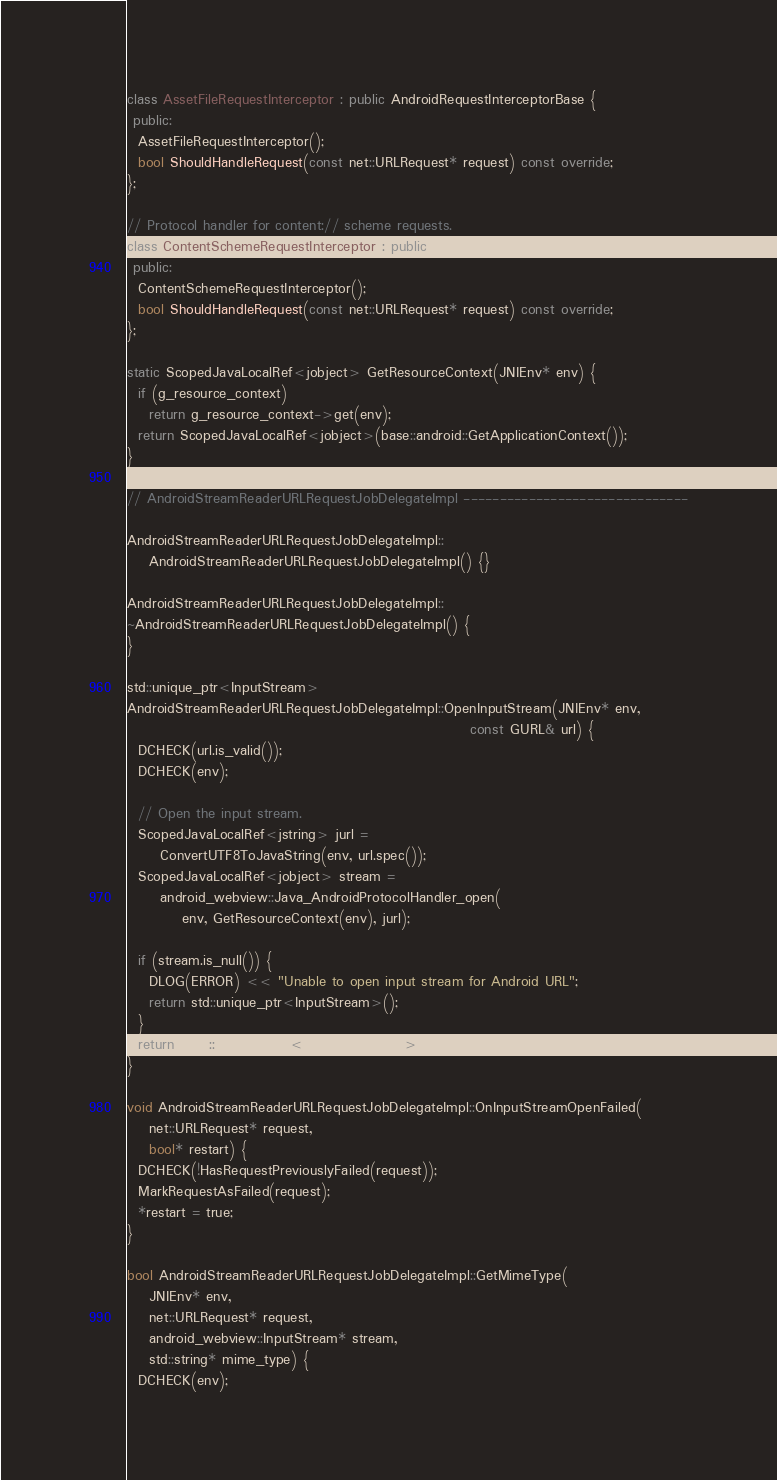<code> <loc_0><loc_0><loc_500><loc_500><_C++_>class AssetFileRequestInterceptor : public AndroidRequestInterceptorBase {
 public:
  AssetFileRequestInterceptor();
  bool ShouldHandleRequest(const net::URLRequest* request) const override;
};

// Protocol handler for content:// scheme requests.
class ContentSchemeRequestInterceptor : public AndroidRequestInterceptorBase {
 public:
  ContentSchemeRequestInterceptor();
  bool ShouldHandleRequest(const net::URLRequest* request) const override;
};

static ScopedJavaLocalRef<jobject> GetResourceContext(JNIEnv* env) {
  if (g_resource_context)
    return g_resource_context->get(env);
  return ScopedJavaLocalRef<jobject>(base::android::GetApplicationContext());
}

// AndroidStreamReaderURLRequestJobDelegateImpl -------------------------------

AndroidStreamReaderURLRequestJobDelegateImpl::
    AndroidStreamReaderURLRequestJobDelegateImpl() {}

AndroidStreamReaderURLRequestJobDelegateImpl::
~AndroidStreamReaderURLRequestJobDelegateImpl() {
}

std::unique_ptr<InputStream>
AndroidStreamReaderURLRequestJobDelegateImpl::OpenInputStream(JNIEnv* env,
                                                              const GURL& url) {
  DCHECK(url.is_valid());
  DCHECK(env);

  // Open the input stream.
  ScopedJavaLocalRef<jstring> jurl =
      ConvertUTF8ToJavaString(env, url.spec());
  ScopedJavaLocalRef<jobject> stream =
      android_webview::Java_AndroidProtocolHandler_open(
          env, GetResourceContext(env), jurl);

  if (stream.is_null()) {
    DLOG(ERROR) << "Unable to open input stream for Android URL";
    return std::unique_ptr<InputStream>();
  }
  return base::MakeUnique<InputStreamImpl>(stream);
}

void AndroidStreamReaderURLRequestJobDelegateImpl::OnInputStreamOpenFailed(
    net::URLRequest* request,
    bool* restart) {
  DCHECK(!HasRequestPreviouslyFailed(request));
  MarkRequestAsFailed(request);
  *restart = true;
}

bool AndroidStreamReaderURLRequestJobDelegateImpl::GetMimeType(
    JNIEnv* env,
    net::URLRequest* request,
    android_webview::InputStream* stream,
    std::string* mime_type) {
  DCHECK(env);</code> 